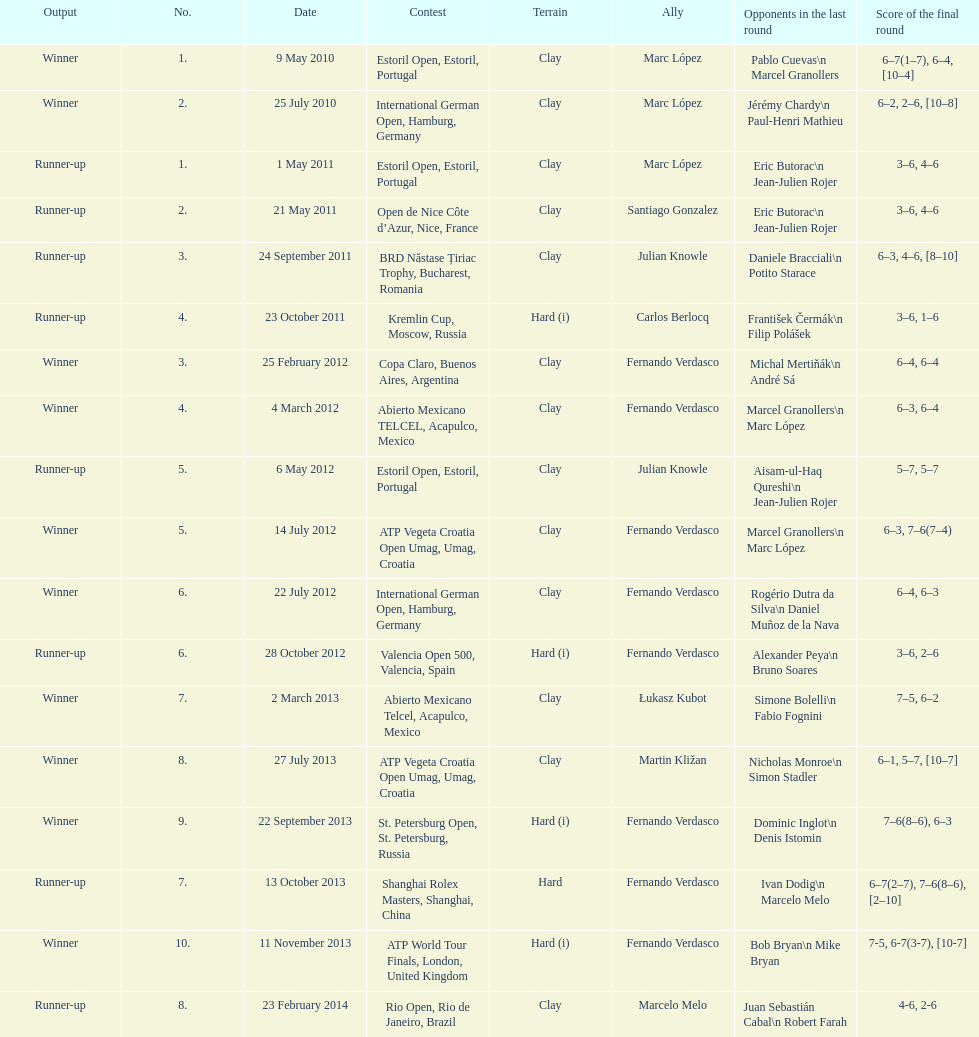What tournament was played after the kremlin cup? Copa Claro, Buenos Aires, Argentina. Parse the table in full. {'header': ['Output', 'No.', 'Date', 'Contest', 'Terrain', 'Ally', 'Opponents in the last round', 'Score of the final round'], 'rows': [['Winner', '1.', '9 May 2010', 'Estoril Open, Estoril, Portugal', 'Clay', 'Marc López', 'Pablo Cuevas\\n Marcel Granollers', '6–7(1–7), 6–4, [10–4]'], ['Winner', '2.', '25 July 2010', 'International German Open, Hamburg, Germany', 'Clay', 'Marc López', 'Jérémy Chardy\\n Paul-Henri Mathieu', '6–2, 2–6, [10–8]'], ['Runner-up', '1.', '1 May 2011', 'Estoril Open, Estoril, Portugal', 'Clay', 'Marc López', 'Eric Butorac\\n Jean-Julien Rojer', '3–6, 4–6'], ['Runner-up', '2.', '21 May 2011', 'Open de Nice Côte d’Azur, Nice, France', 'Clay', 'Santiago Gonzalez', 'Eric Butorac\\n Jean-Julien Rojer', '3–6, 4–6'], ['Runner-up', '3.', '24 September 2011', 'BRD Năstase Țiriac Trophy, Bucharest, Romania', 'Clay', 'Julian Knowle', 'Daniele Bracciali\\n Potito Starace', '6–3, 4–6, [8–10]'], ['Runner-up', '4.', '23 October 2011', 'Kremlin Cup, Moscow, Russia', 'Hard (i)', 'Carlos Berlocq', 'František Čermák\\n Filip Polášek', '3–6, 1–6'], ['Winner', '3.', '25 February 2012', 'Copa Claro, Buenos Aires, Argentina', 'Clay', 'Fernando Verdasco', 'Michal Mertiňák\\n André Sá', '6–4, 6–4'], ['Winner', '4.', '4 March 2012', 'Abierto Mexicano TELCEL, Acapulco, Mexico', 'Clay', 'Fernando Verdasco', 'Marcel Granollers\\n Marc López', '6–3, 6–4'], ['Runner-up', '5.', '6 May 2012', 'Estoril Open, Estoril, Portugal', 'Clay', 'Julian Knowle', 'Aisam-ul-Haq Qureshi\\n Jean-Julien Rojer', '5–7, 5–7'], ['Winner', '5.', '14 July 2012', 'ATP Vegeta Croatia Open Umag, Umag, Croatia', 'Clay', 'Fernando Verdasco', 'Marcel Granollers\\n Marc López', '6–3, 7–6(7–4)'], ['Winner', '6.', '22 July 2012', 'International German Open, Hamburg, Germany', 'Clay', 'Fernando Verdasco', 'Rogério Dutra da Silva\\n Daniel Muñoz de la Nava', '6–4, 6–3'], ['Runner-up', '6.', '28 October 2012', 'Valencia Open 500, Valencia, Spain', 'Hard (i)', 'Fernando Verdasco', 'Alexander Peya\\n Bruno Soares', '3–6, 2–6'], ['Winner', '7.', '2 March 2013', 'Abierto Mexicano Telcel, Acapulco, Mexico', 'Clay', 'Łukasz Kubot', 'Simone Bolelli\\n Fabio Fognini', '7–5, 6–2'], ['Winner', '8.', '27 July 2013', 'ATP Vegeta Croatia Open Umag, Umag, Croatia', 'Clay', 'Martin Kližan', 'Nicholas Monroe\\n Simon Stadler', '6–1, 5–7, [10–7]'], ['Winner', '9.', '22 September 2013', 'St. Petersburg Open, St. Petersburg, Russia', 'Hard (i)', 'Fernando Verdasco', 'Dominic Inglot\\n Denis Istomin', '7–6(8–6), 6–3'], ['Runner-up', '7.', '13 October 2013', 'Shanghai Rolex Masters, Shanghai, China', 'Hard', 'Fernando Verdasco', 'Ivan Dodig\\n Marcelo Melo', '6–7(2–7), 7–6(8–6), [2–10]'], ['Winner', '10.', '11 November 2013', 'ATP World Tour Finals, London, United Kingdom', 'Hard (i)', 'Fernando Verdasco', 'Bob Bryan\\n Mike Bryan', '7-5, 6-7(3-7), [10-7]'], ['Runner-up', '8.', '23 February 2014', 'Rio Open, Rio de Janeiro, Brazil', 'Clay', 'Marcelo Melo', 'Juan Sebastián Cabal\\n Robert Farah', '4-6, 2-6']]} 